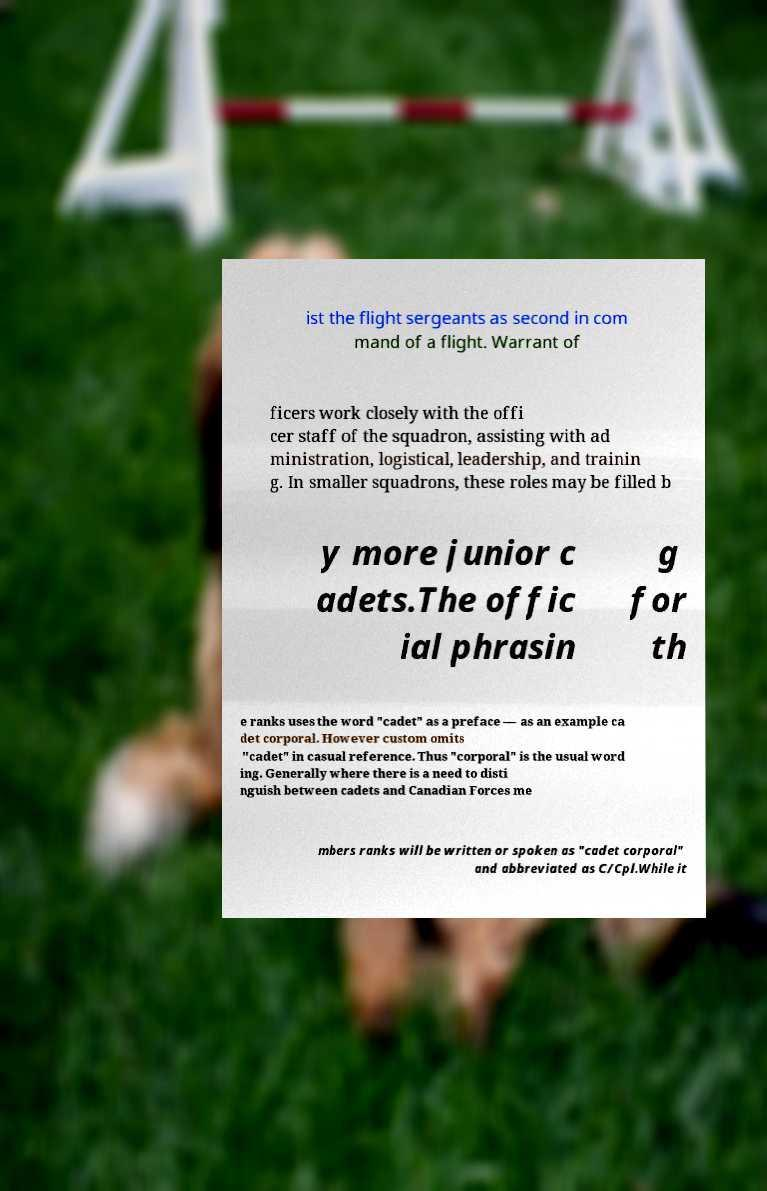Could you extract and type out the text from this image? ist the flight sergeants as second in com mand of a flight. Warrant of ficers work closely with the offi cer staff of the squadron, assisting with ad ministration, logistical, leadership, and trainin g. In smaller squadrons, these roles may be filled b y more junior c adets.The offic ial phrasin g for th e ranks uses the word "cadet" as a preface — as an example ca det corporal. However custom omits "cadet" in casual reference. Thus "corporal" is the usual word ing. Generally where there is a need to disti nguish between cadets and Canadian Forces me mbers ranks will be written or spoken as "cadet corporal" and abbreviated as C/Cpl.While it 